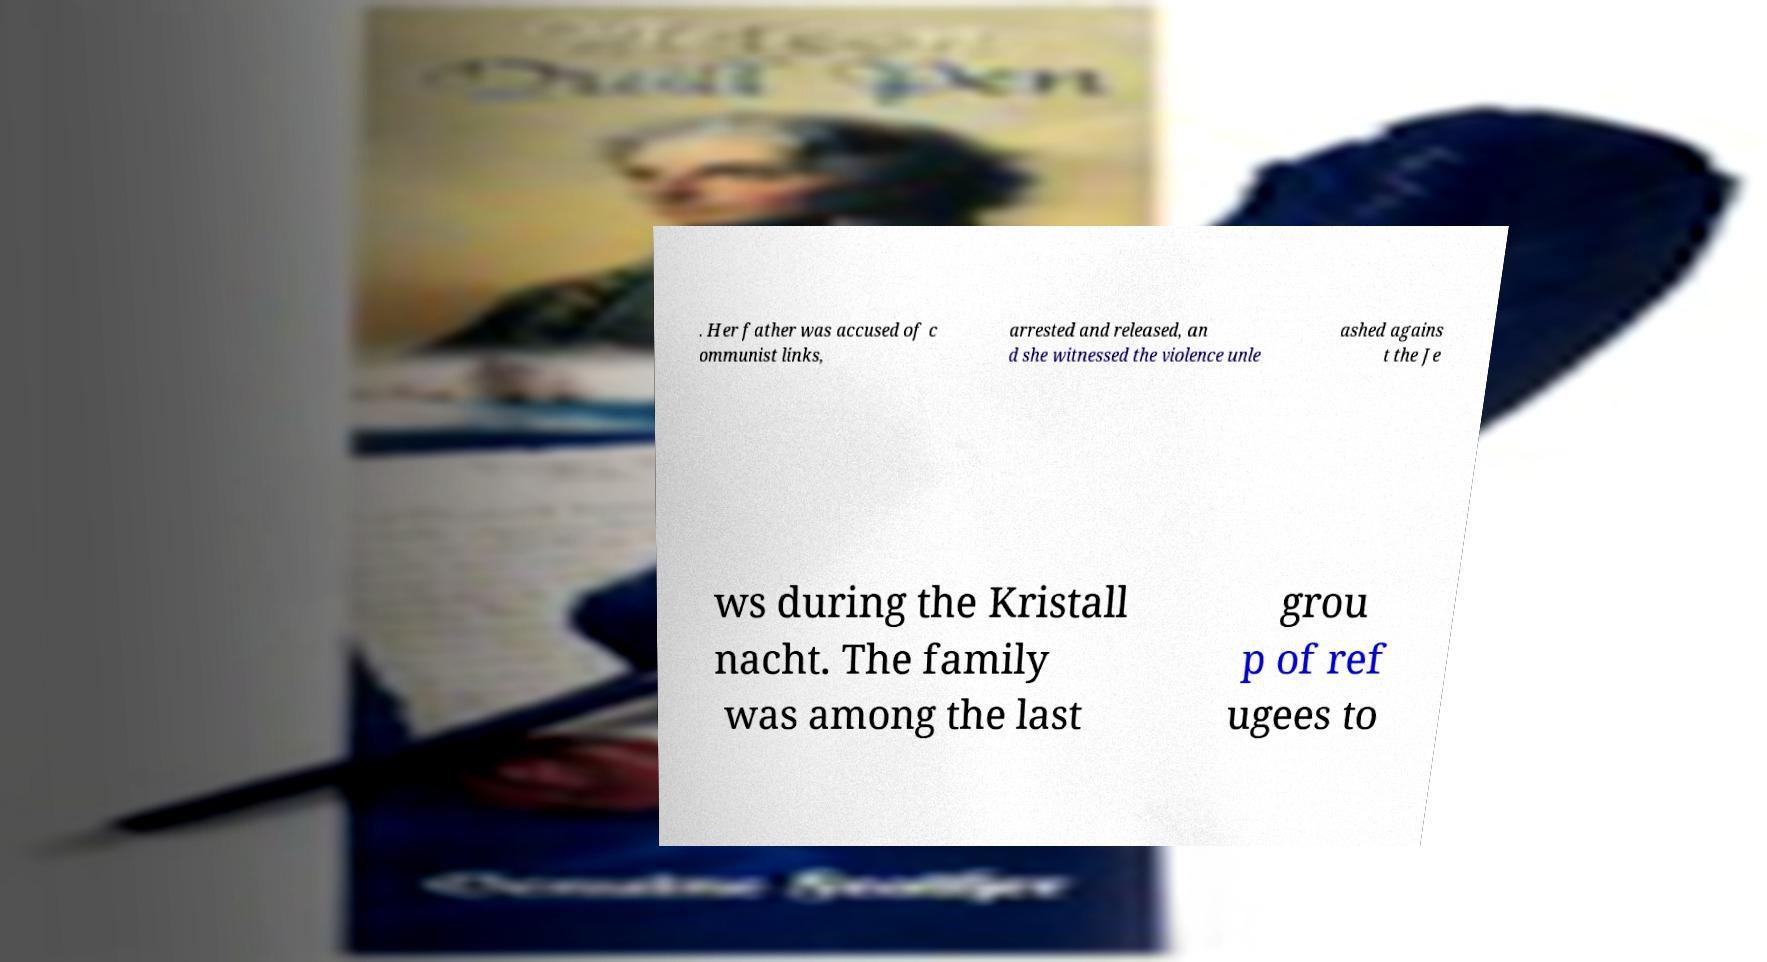Could you assist in decoding the text presented in this image and type it out clearly? . Her father was accused of c ommunist links, arrested and released, an d she witnessed the violence unle ashed agains t the Je ws during the Kristall nacht. The family was among the last grou p of ref ugees to 